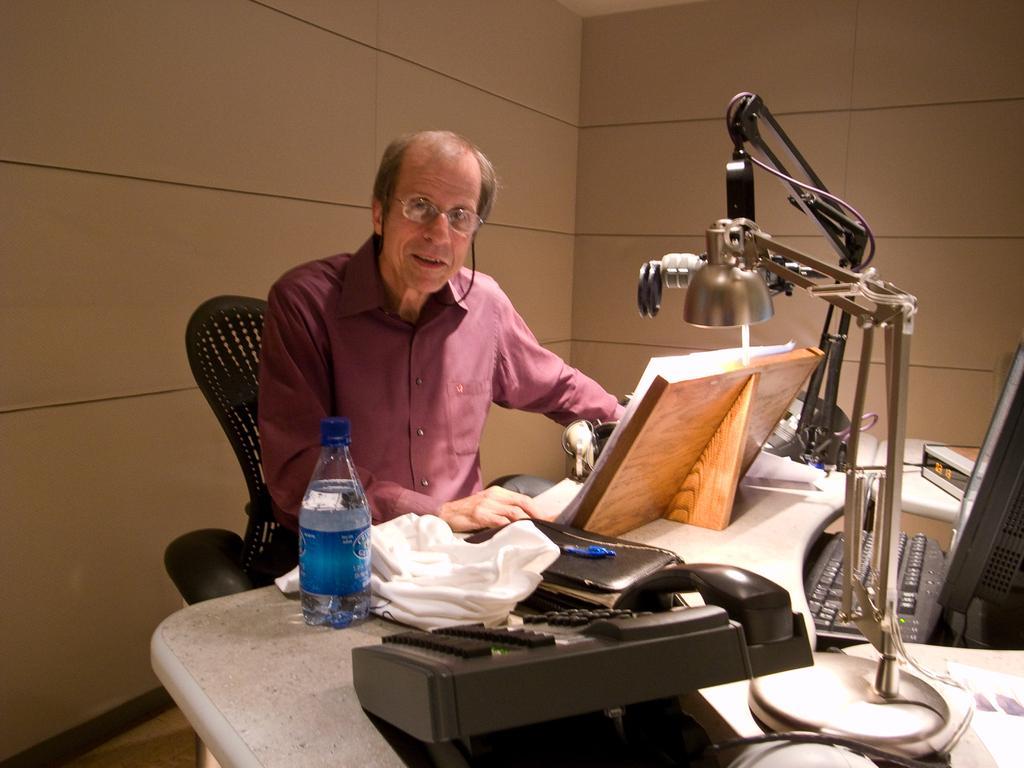Please provide a concise description of this image. This picture shows a man sitting in the chair in front of a table on which telephone, files, cloth, water bottle and a lamp is placed. There's a computer on the table too. The man is wearing a spectacles. In the background there is a wall. 